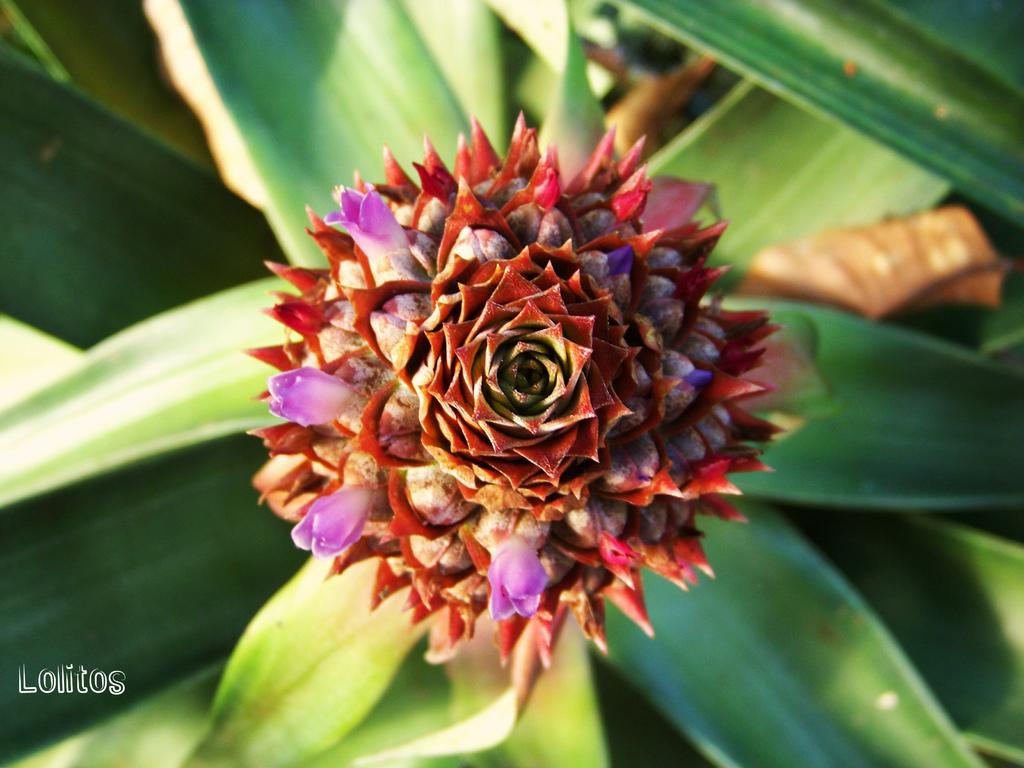What is present in the picture? There is a plant in the picture. Can you describe the plant's flowers? The plant has a flower with red petals and small flowers that are violet in color. How many hours does the plant sleep in the image? Plants do not sleep, so this question cannot be answered based on the information provided. 